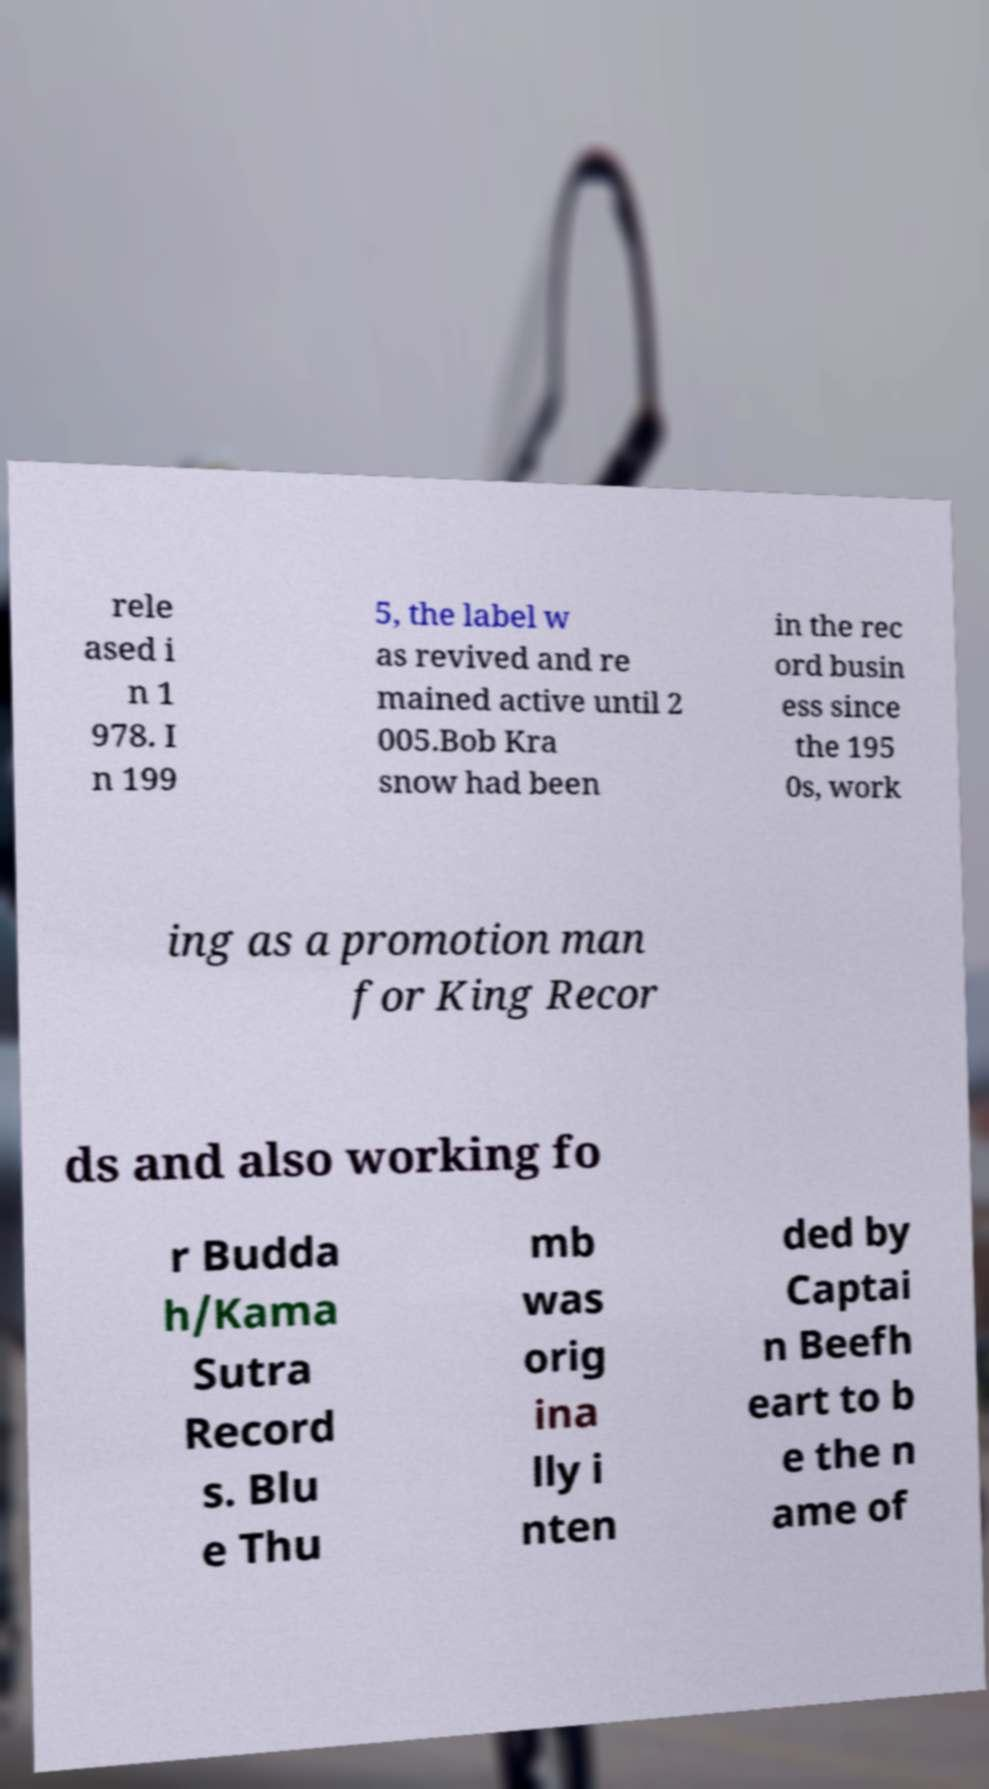There's text embedded in this image that I need extracted. Can you transcribe it verbatim? rele ased i n 1 978. I n 199 5, the label w as revived and re mained active until 2 005.Bob Kra snow had been in the rec ord busin ess since the 195 0s, work ing as a promotion man for King Recor ds and also working fo r Budda h/Kama Sutra Record s. Blu e Thu mb was orig ina lly i nten ded by Captai n Beefh eart to b e the n ame of 